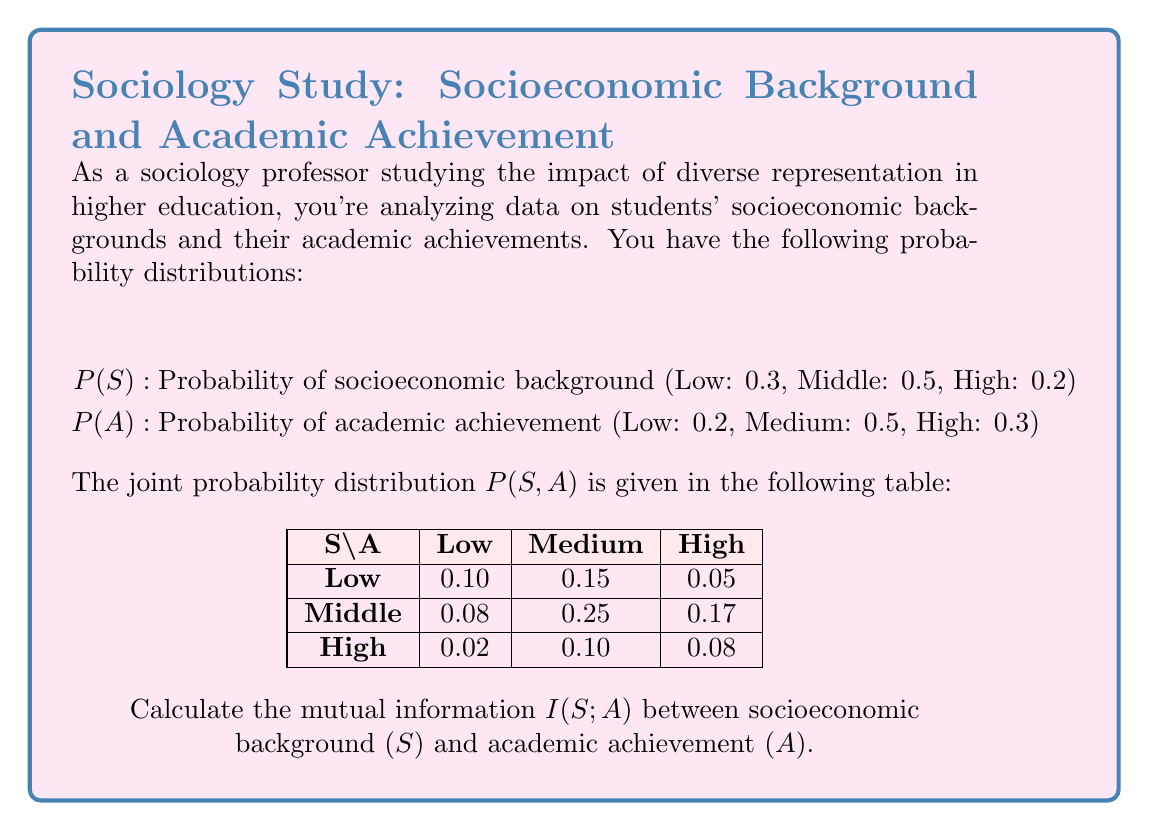Could you help me with this problem? To calculate the mutual information I(S;A), we'll follow these steps:

1) First, recall the formula for mutual information:

   $$I(S;A) = \sum_{s \in S} \sum_{a \in A} P(s,a) \log_2 \frac{P(s,a)}{P(s)P(a)}$$

2) We need to calculate P(S) and P(A) from the given joint probability distribution:

   P(S): Low = 0.30, Middle = 0.50, High = 0.20
   P(A): Low = 0.20, Medium = 0.50, High = 0.30

3) Now, we'll calculate each term of the sum:

   For S = Low, A = Low:
   $$0.10 \log_2 \frac{0.10}{0.30 \cdot 0.20} = 0.10 \log_2 1.6667 = 0.0736$$

   For S = Low, A = Medium:
   $$0.15 \log_2 \frac{0.15}{0.30 \cdot 0.50} = 0.15 \log_2 1 = 0$$

   For S = Low, A = High:
   $$0.05 \log_2 \frac{0.05}{0.30 \cdot 0.30} = 0.05 \log_2 0.5556 = -0.0425$$

   For S = Middle, A = Low:
   $$0.08 \log_2 \frac{0.08}{0.50 \cdot 0.20} = 0.08 \log_2 0.8 = -0.0286$$

   For S = Middle, A = Medium:
   $$0.25 \log_2 \frac{0.25}{0.50 \cdot 0.50} = 0.25 \log_2 1 = 0$$

   For S = Middle, A = High:
   $$0.17 \log_2 \frac{0.17}{0.50 \cdot 0.30} = 0.17 \log_2 1.1333 = 0.0209$$

   For S = High, A = Low:
   $$0.02 \log_2 \frac{0.02}{0.20 \cdot 0.20} = 0.02 \log_2 0.5 = -0.0200$$

   For S = High, A = Medium:
   $$0.10 \log_2 \frac{0.10}{0.20 \cdot 0.50} = 0.10 \log_2 1 = 0$$

   For S = High, A = High:
   $$0.08 \log_2 \frac{0.08}{0.20 \cdot 0.30} = 0.08 \log_2 1.3333 = 0.0306$$

4) Sum all these terms:

   $$I(S;A) = 0.0736 + 0 - 0.0425 - 0.0286 + 0 + 0.0209 - 0.0200 + 0 + 0.0306 = 0.0340$$

5) Therefore, the mutual information I(S;A) is approximately 0.0340 bits.
Answer: $I(S;A) \approx 0.0340$ bits 